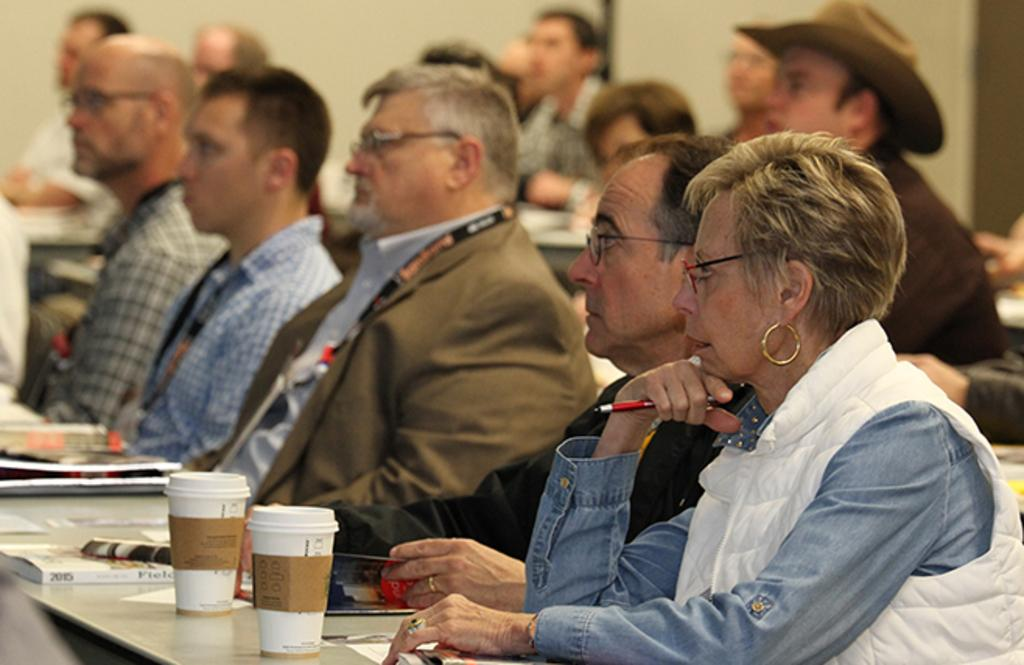What are the people in the image doing? The people in the image are sitting. What is a person holding in the image? A person is holding a pen. What objects can be seen on the table in the image? There are glasses, books, and papers on the table. What is visible in the background of the image? There is a wall in the background of the image. What type of orange can be seen hanging from the wall in the image? There is no orange present in the image; it only features people sitting, a pen, glasses, books, papers, and a wall in the background. 